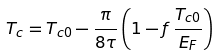Convert formula to latex. <formula><loc_0><loc_0><loc_500><loc_500>T _ { c } = T _ { c 0 } - \frac { \pi } { 8 \tau } \left ( 1 - f \, \frac { T _ { c 0 } } { E _ { F } } \right )</formula> 